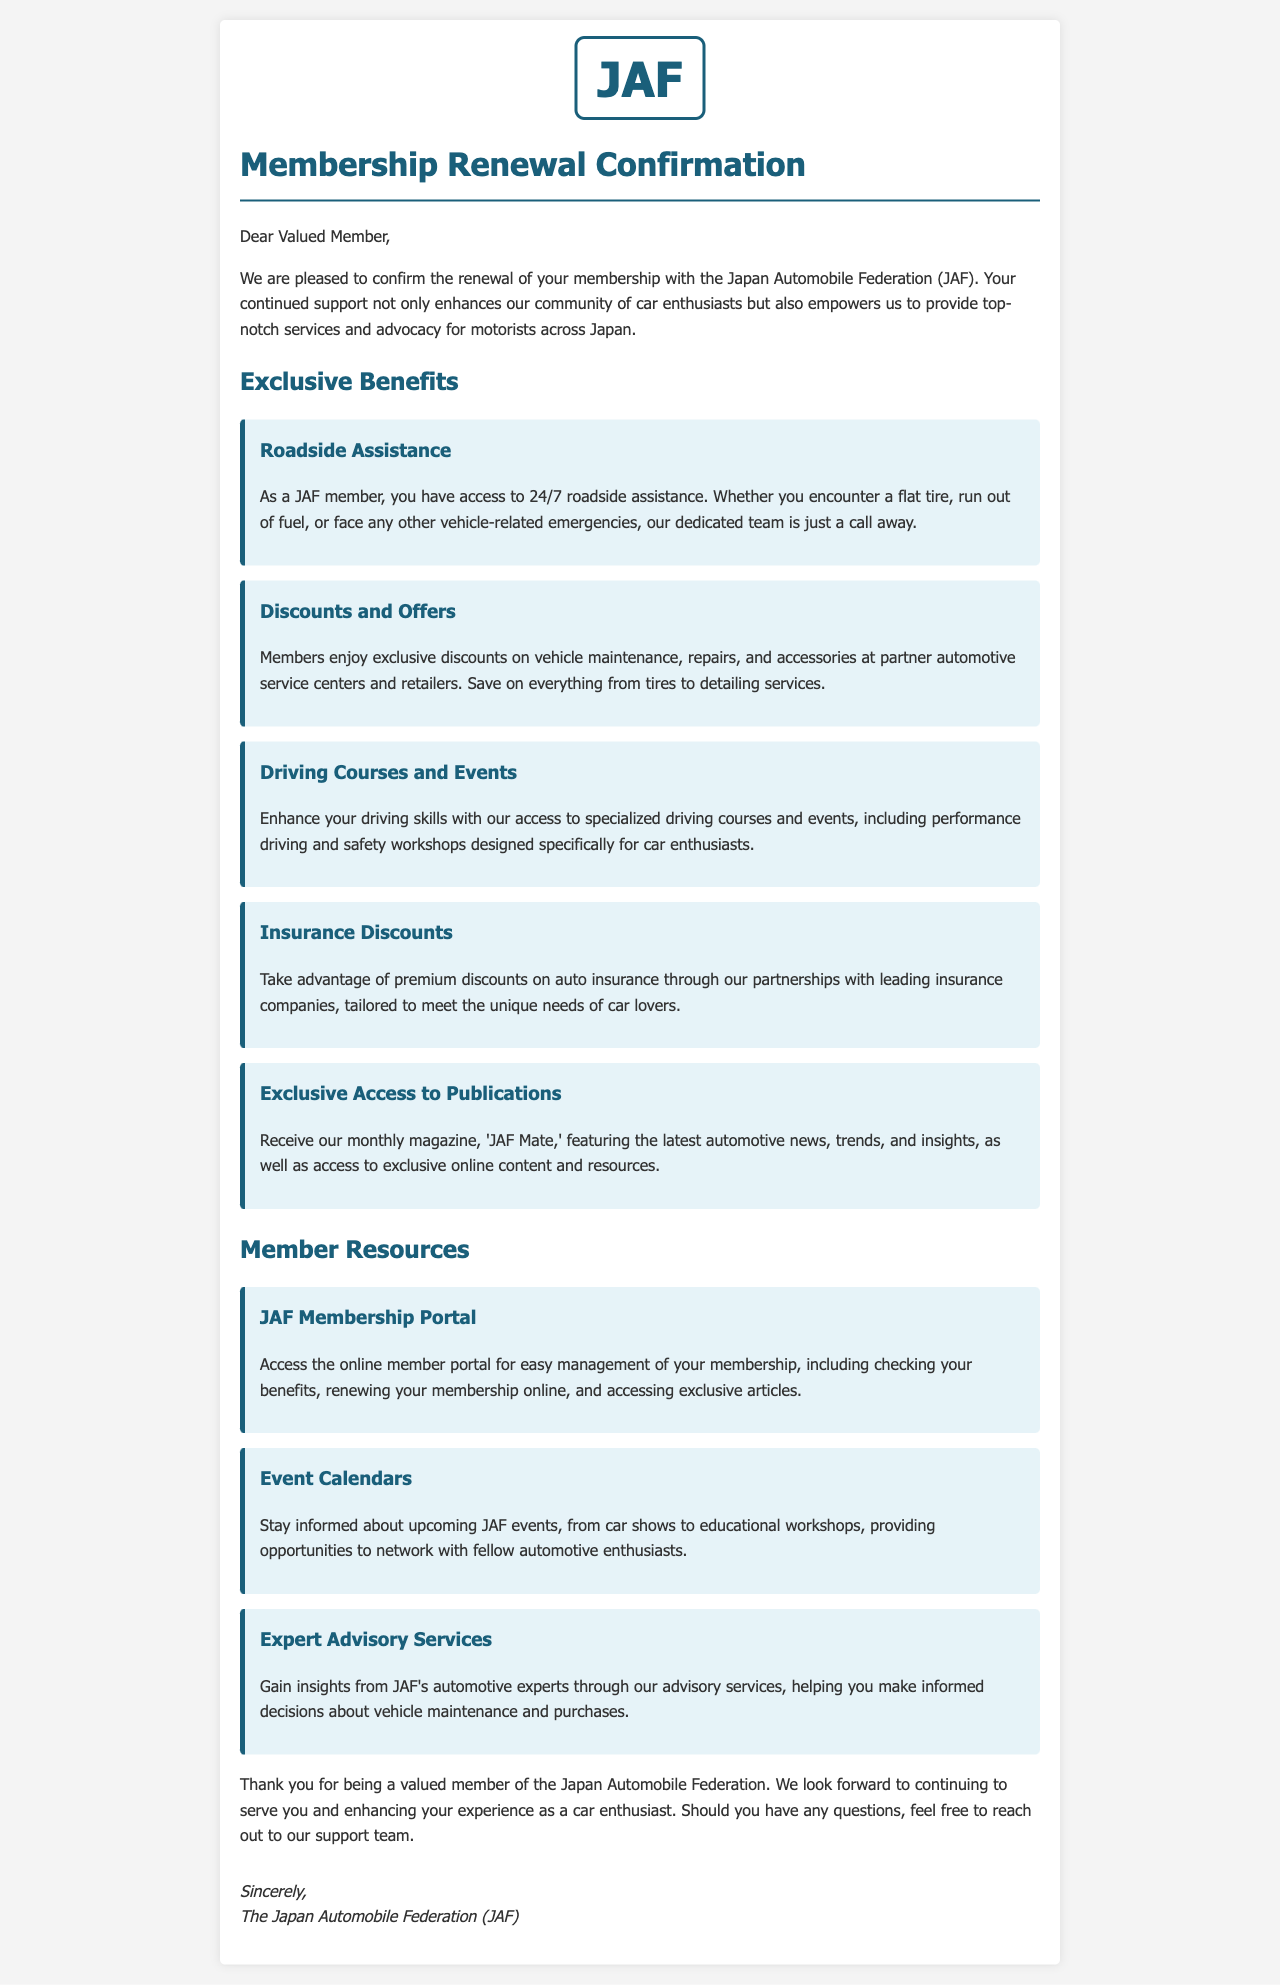What is the name of the magazine members receive? The magazine members receive is highlighted in the document as a benefit, specifically mentioned in the exclusive access section.
Answer: JAF Mate What type of assistance do members receive 24/7? This question refers to the first listed benefit, where the document specifies the type of assistance available to members.
Answer: Roadside Assistance How many exclusive benefits are listed in the document? The number of exclusive benefits can be counted from the discrete benefits enumerated in the document.
Answer: Five Which organization is sending this membership confirmation? The document concludes with a signature indicating the organization responsible for sending the letter.
Answer: Japan Automobile Federation (JAF) What can members do through the JAF Membership Portal? This involved recalling details from the information described in the member resources section regarding what can be managed online.
Answer: Manage membership What kind of events can members stay informed about? The document mentions upcoming activities that members can keep track of, pointing towards the type of events available.
Answer: JAF events What is the purpose of the Expert Advisory Services? This was addressed in the resource section that outlines the support available to members that informs their decisions.
Answer: Inform decisions What type of courses do JAF members have access to? This question refers to the specific type of courses and workshops mentioned in the benefits outlining personal skill development.
Answer: Driving courses 